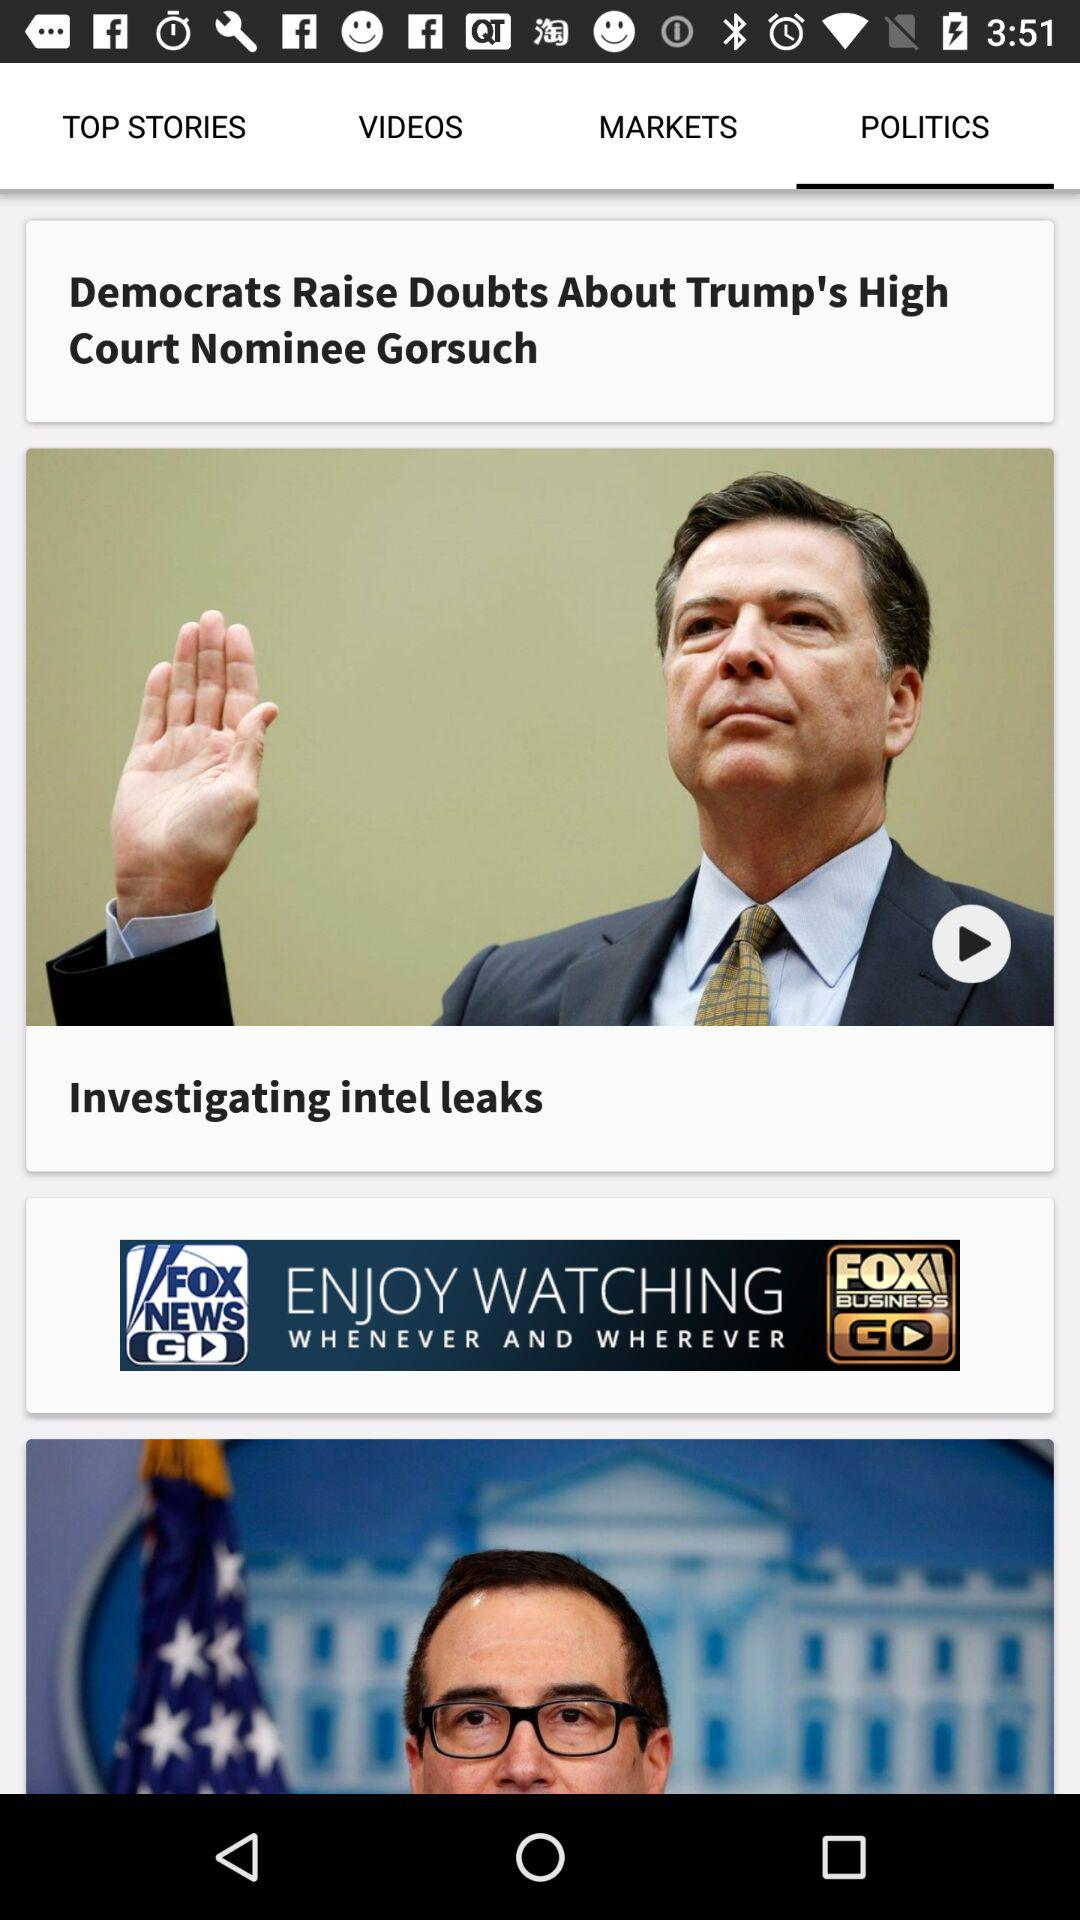What is the headline of the "POLITICS" news? The headline is "Democrats Raise Doubts About Trump's High Court Nominee Gorsuch". 